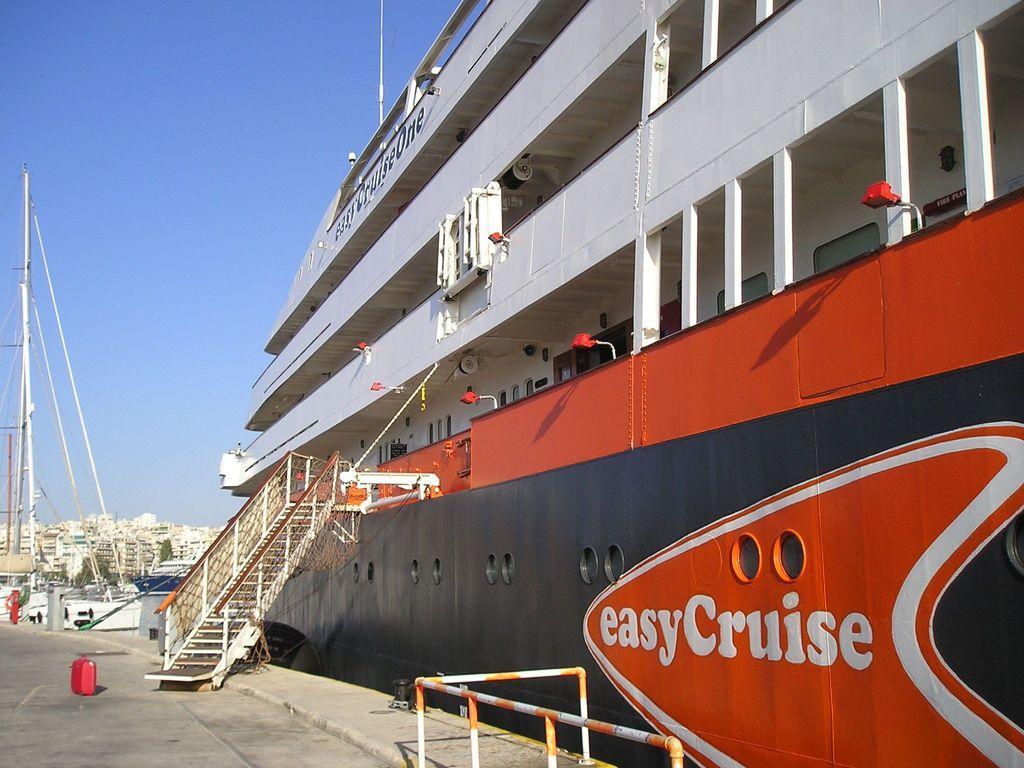Please provide a concise description of this image. In this image there is a ship. There is text on the ship. To the left there is the ground. There is a railing on the ground. There are steps from the ship to the ground. In the background there are buildings and trees. At the top there is the sky. 